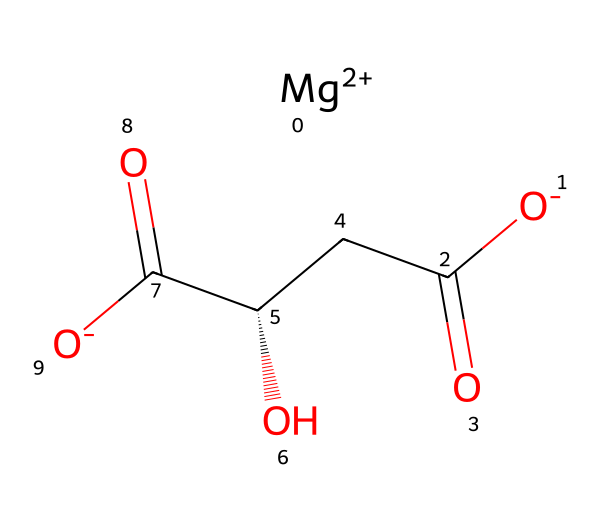How many magnesium ions are present in this structure? The structure shows a single magnesium ion, denoted by "[Mg+2]", indicating that there is one magnesium atom with a +2 charge.
Answer: one What is the oxidation state of magnesium in this molecule? In the SMILES representation, "[Mg+2]" indicates that magnesium has lost two electrons, giving it a +2 oxidation state.
Answer: +2 What type of compound is represented by this structure? The presence of the carboxylate groups "C(=O)[O-]" and the magnesium ion suggests this is an electrolyte compound, primarily used in hydration products.
Answer: electrolyte How many carboxylate groups are in this molecule? The structure shows two instances of "C(=O)[O-]", each representing a carboxylate group, which totals two in the molecule.
Answer: two What functional groups are present in this structure? The notable functional groups include carboxylate (as indicated by "C(=O)[O-]") and hydroxyl (as indicated by "C[C@H](O)").
Answer: carboxylate and hydroxyl Explain how this compound might affect hydration. The presence of magnesium and the carboxylate groups allows this compound to help regulate electrolyte balance in the body, enhancing hydration levels by maintaining fluid balance.
Answer: regulates electrolytes for hydration 